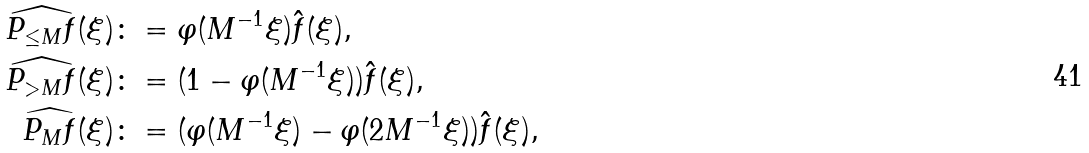<formula> <loc_0><loc_0><loc_500><loc_500>\widehat { P _ { \leq M } f } ( \xi ) & \colon = \varphi ( M ^ { - 1 } \xi ) \hat { f } ( \xi ) , \\ \widehat { P _ { > M } f } ( \xi ) & \colon = ( 1 - \varphi ( M ^ { - 1 } \xi ) ) \hat { f } ( \xi ) , \\ \widehat { P _ { M } f } ( \xi ) & \colon = ( \varphi ( M ^ { - 1 } \xi ) - \varphi ( 2 M ^ { - 1 } \xi ) ) \hat { f } ( \xi ) ,</formula> 